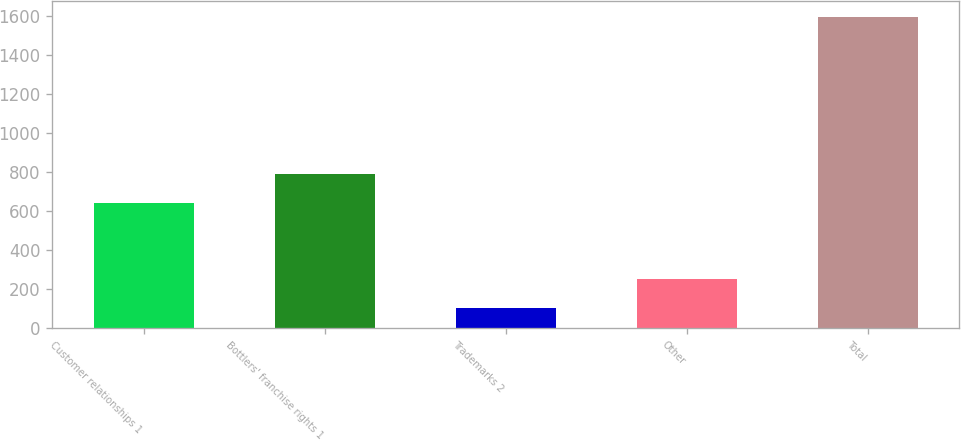Convert chart. <chart><loc_0><loc_0><loc_500><loc_500><bar_chart><fcel>Customer relationships 1<fcel>Bottlers' franchise rights 1<fcel>Trademarks 2<fcel>Other<fcel>Total<nl><fcel>642<fcel>791.2<fcel>105<fcel>254.2<fcel>1597<nl></chart> 